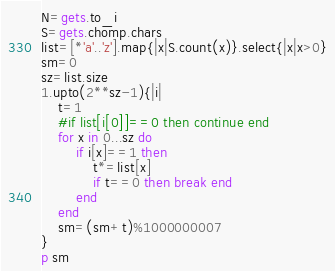Convert code to text. <code><loc_0><loc_0><loc_500><loc_500><_Ruby_>N=gets.to_i
S=gets.chomp.chars
list=[*'a'..'z'].map{|x|S.count(x)}.select{|x|x>0}
sm=0
sz=list.size
1.upto(2**sz-1){|i|
    t=1
    #if list[i[0]]==0 then continue end 
    for x in 0...sz do
        if i[x]==1 then
            t*=list[x]
            if t==0 then break end
        end
    end
    sm=(sm+t)%1000000007
}
p sm</code> 